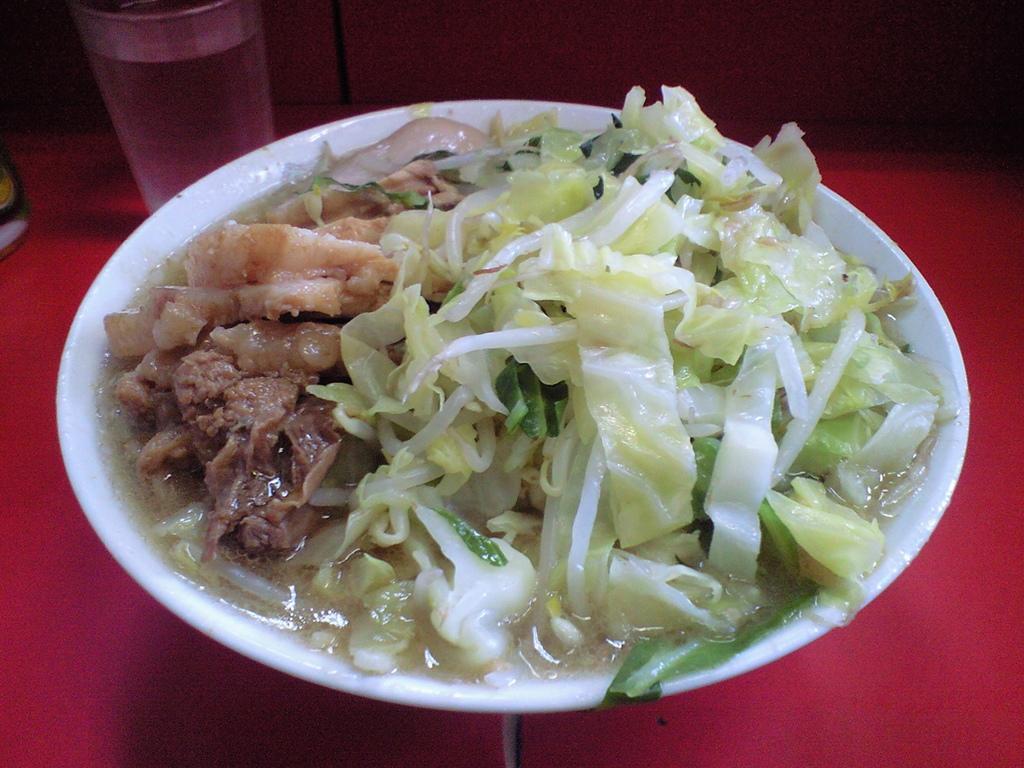Could you give a brief overview of what you see in this image? In this picture I can see food in the bowl and I can see a glass with some liquid on the table 